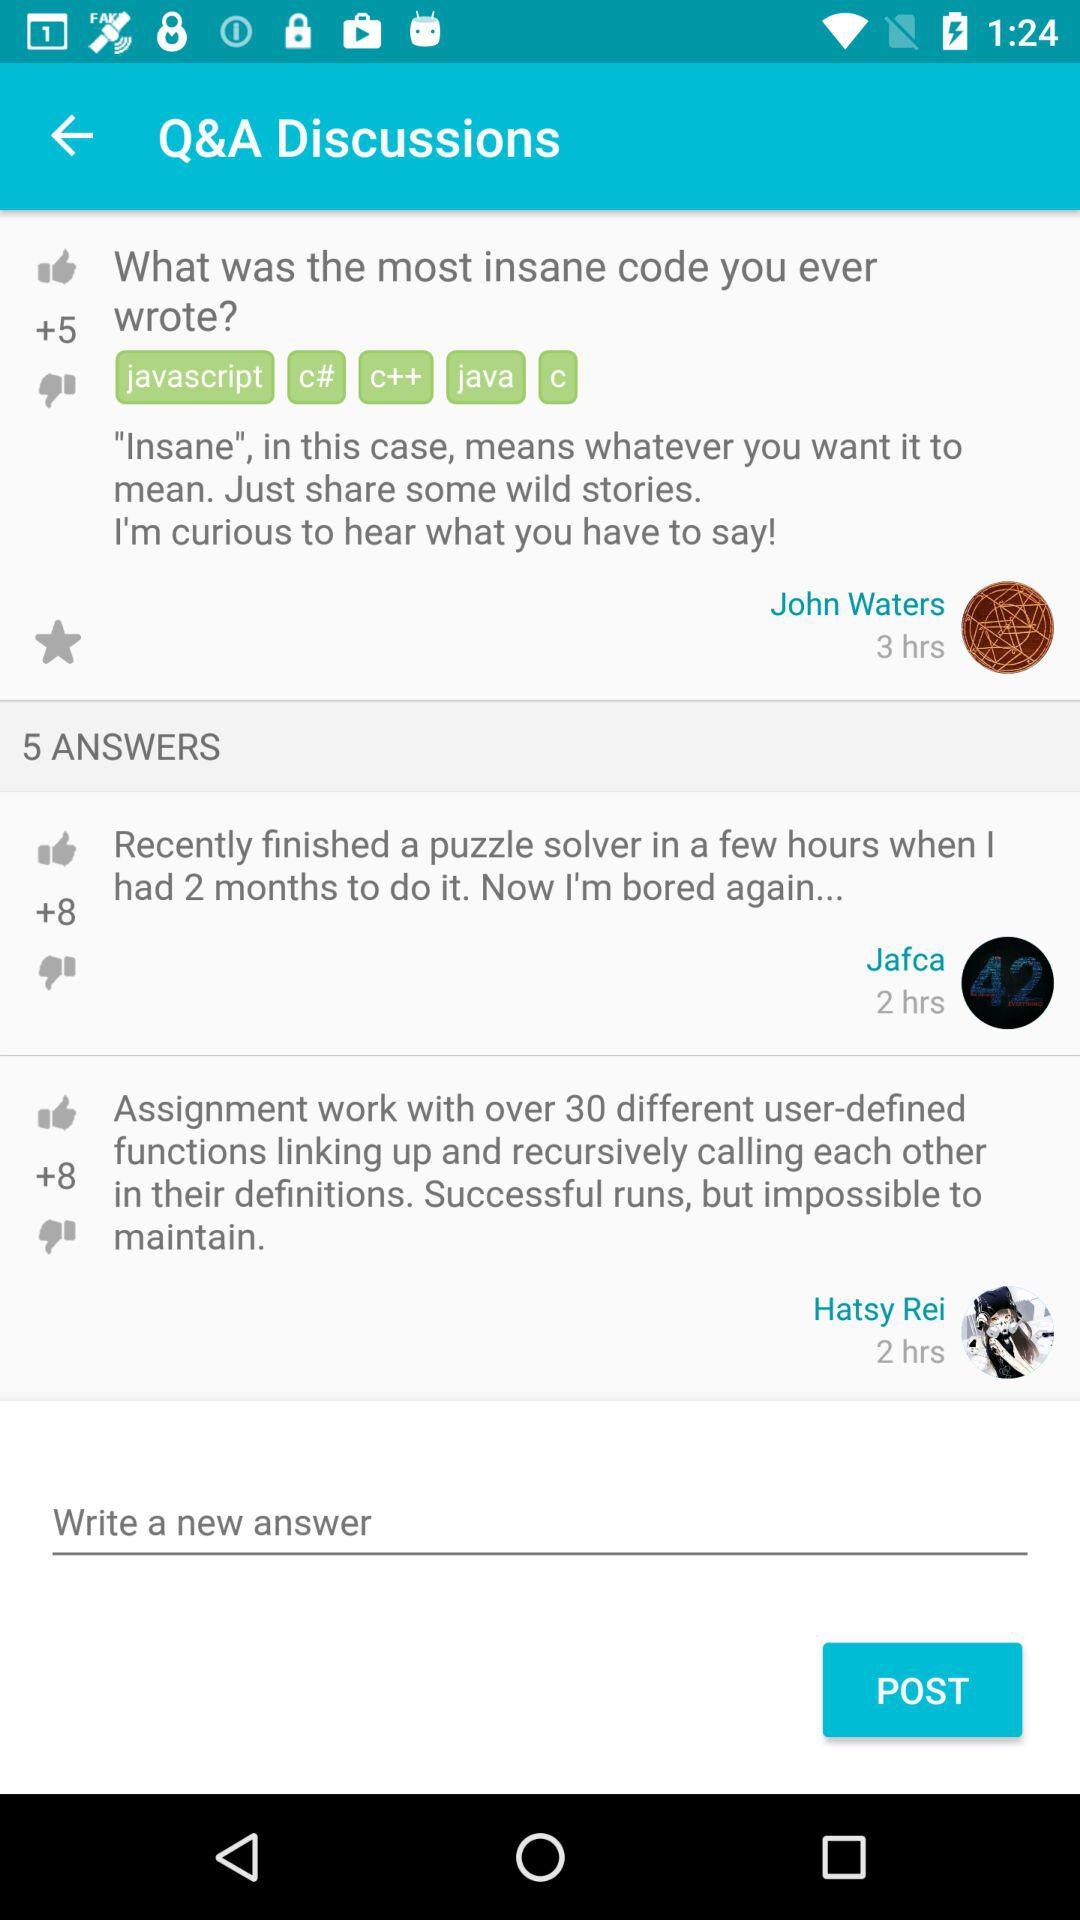Who asked the question? The question was asked by John Waters. 